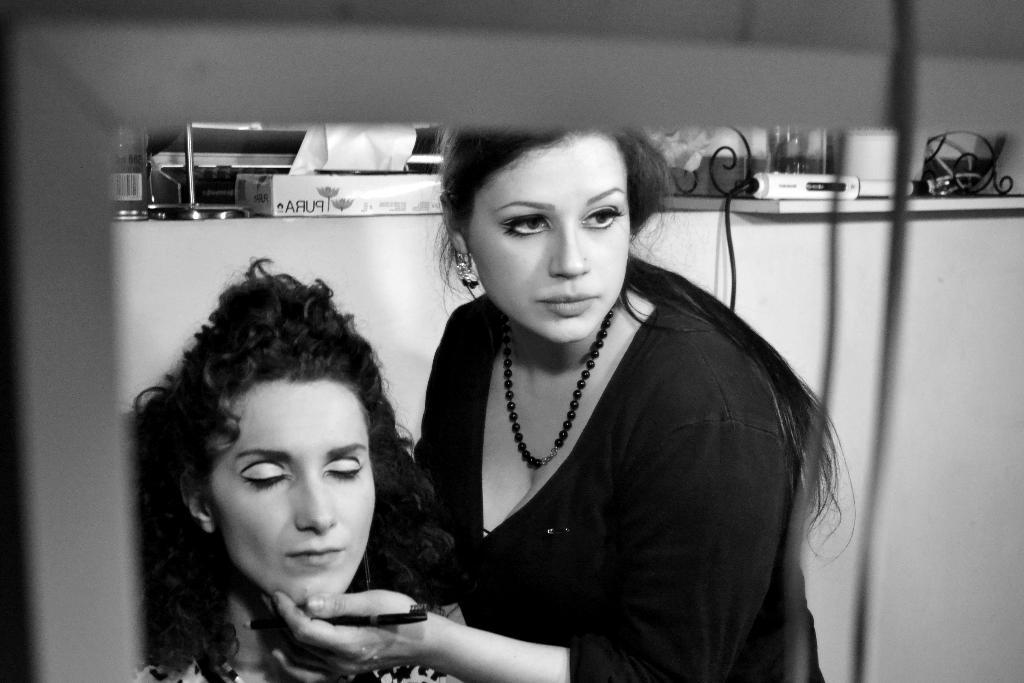How many people are in the image? There are two women in the image. What is the color scheme of the image? The image is in black and white. What can be seen in the background of the image? There is a machine visible in the background of the image, along with other unspecified objects. What time is displayed on the clock in the image? There is no clock present in the image. How many attempts did the drawer make in the image? There is no drawer or any attempt-related activity in the image. 